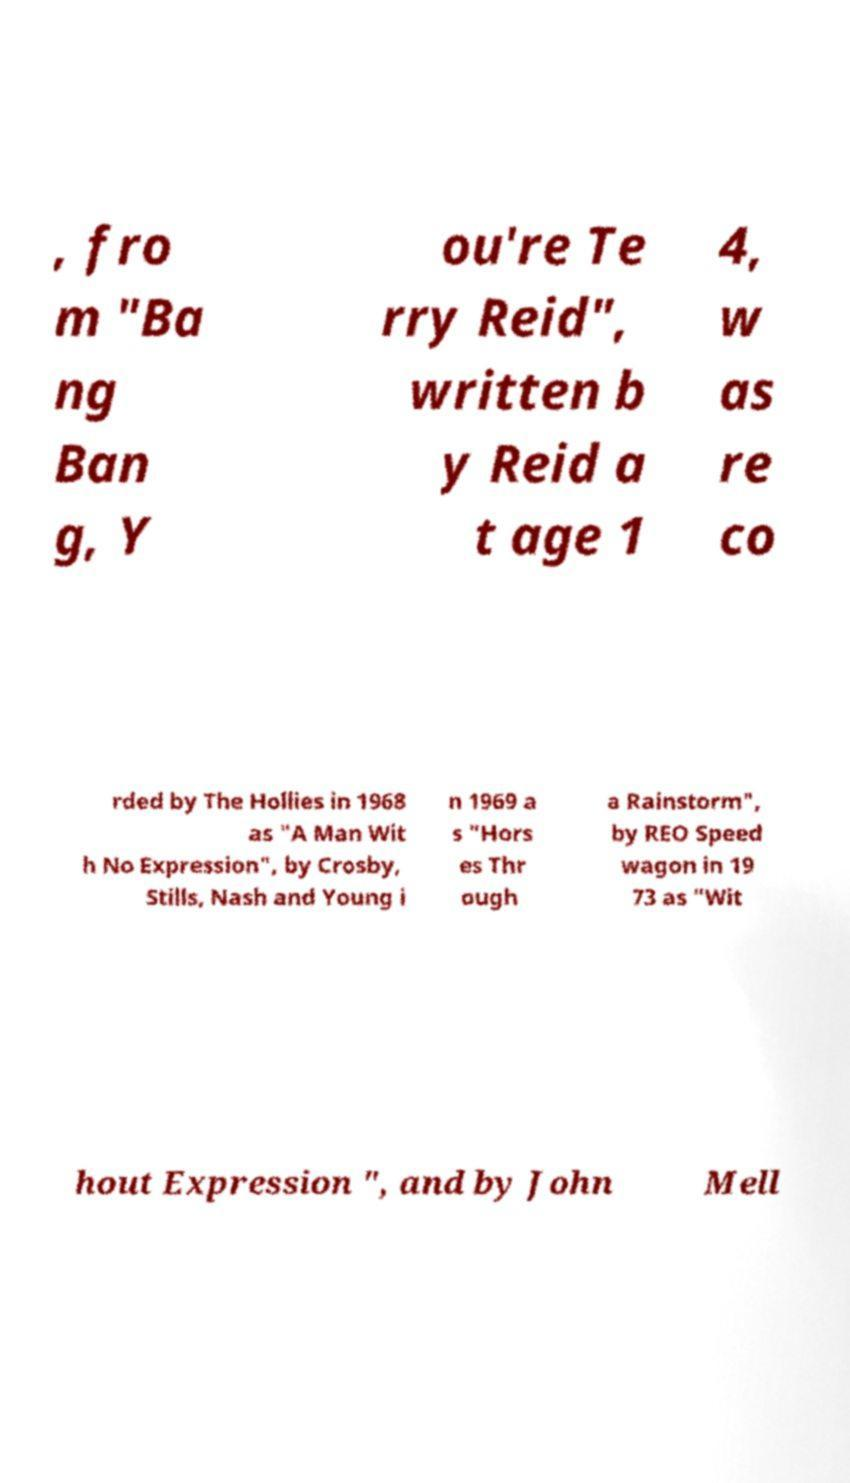Please read and relay the text visible in this image. What does it say? , fro m "Ba ng Ban g, Y ou're Te rry Reid", written b y Reid a t age 1 4, w as re co rded by The Hollies in 1968 as "A Man Wit h No Expression", by Crosby, Stills, Nash and Young i n 1969 a s "Hors es Thr ough a Rainstorm", by REO Speed wagon in 19 73 as "Wit hout Expression ", and by John Mell 